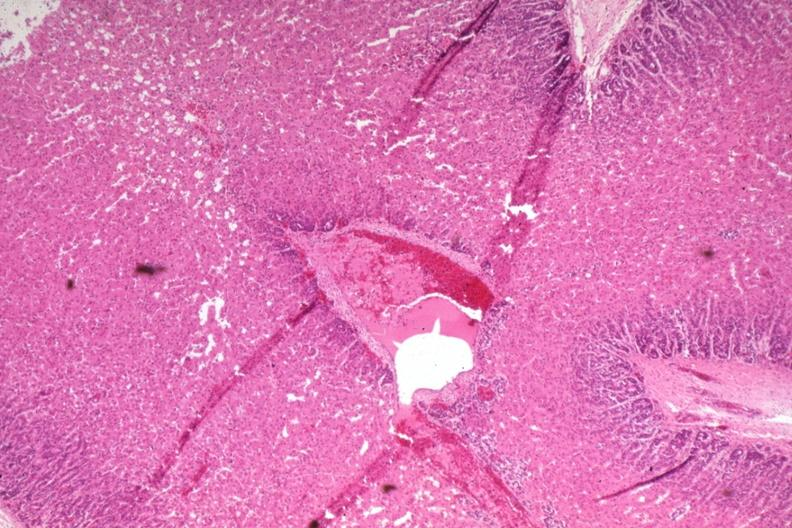where is this part in the figure?
Answer the question using a single word or phrase. Endocrine system 